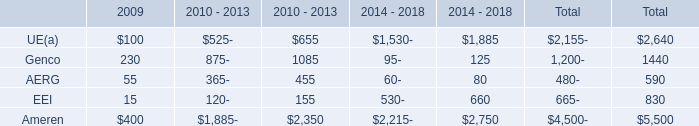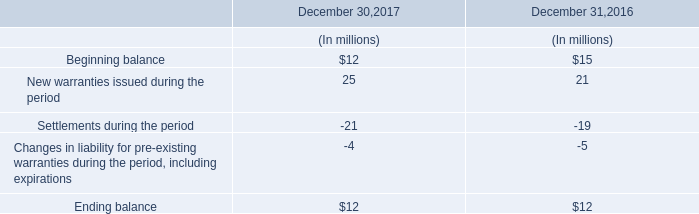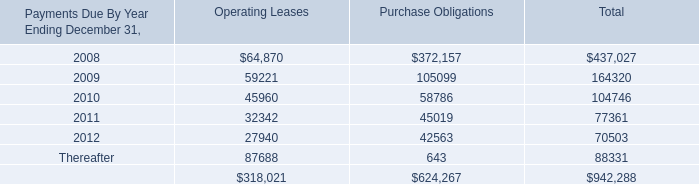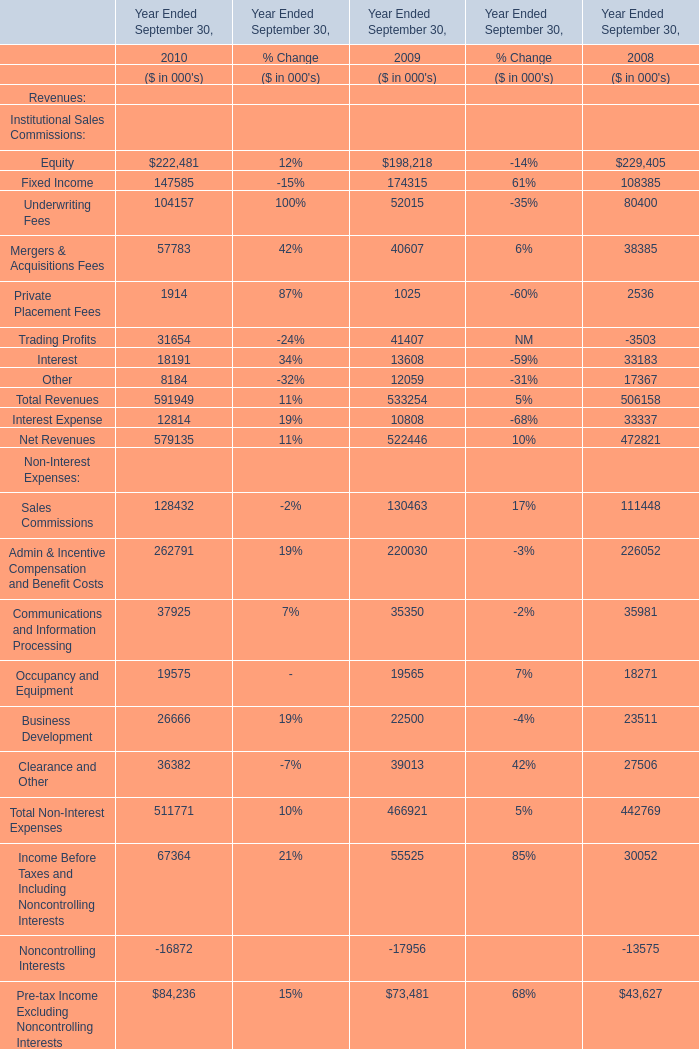As As the chart 3 shows,which Year Ended September 30 is Total Revenues the lowest? 
Answer: 2008. 